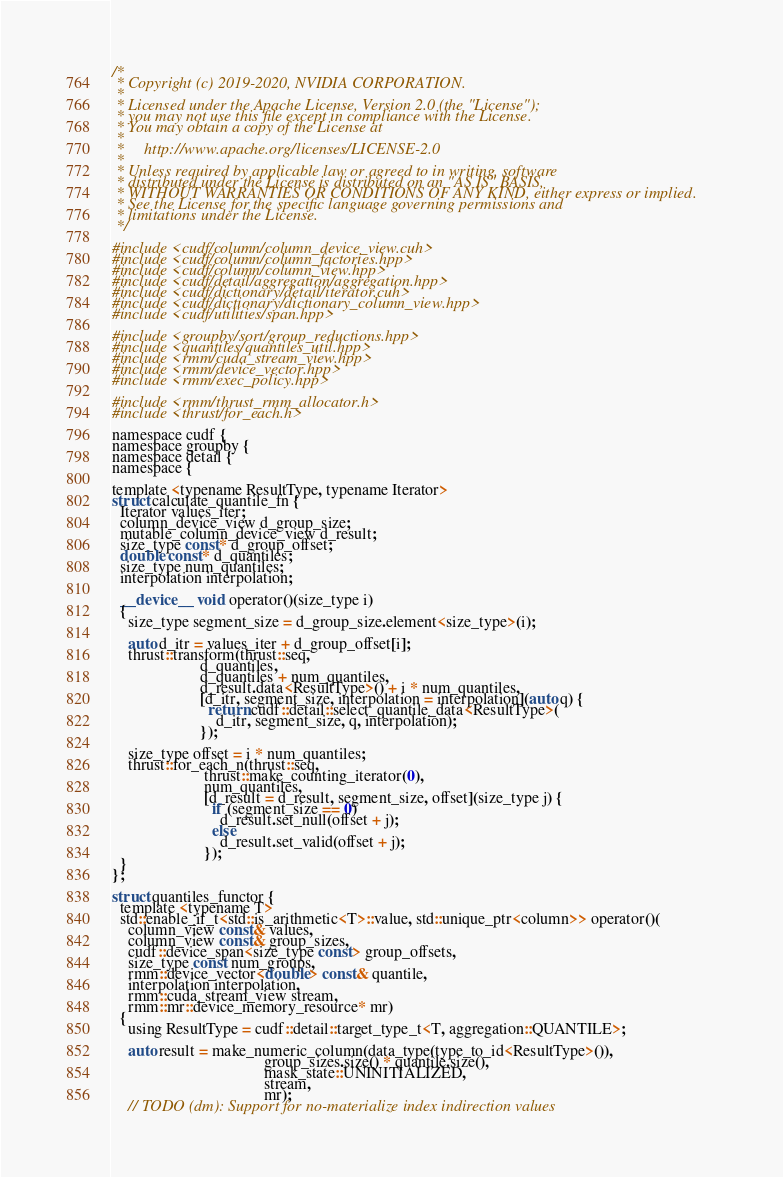Convert code to text. <code><loc_0><loc_0><loc_500><loc_500><_Cuda_>/*
 * Copyright (c) 2019-2020, NVIDIA CORPORATION.
 *
 * Licensed under the Apache License, Version 2.0 (the "License");
 * you may not use this file except in compliance with the License.
 * You may obtain a copy of the License at
 *
 *     http://www.apache.org/licenses/LICENSE-2.0
 *
 * Unless required by applicable law or agreed to in writing, software
 * distributed under the License is distributed on an "AS IS" BASIS,
 * WITHOUT WARRANTIES OR CONDITIONS OF ANY KIND, either express or implied.
 * See the License for the specific language governing permissions and
 * limitations under the License.
 */

#include <cudf/column/column_device_view.cuh>
#include <cudf/column/column_factories.hpp>
#include <cudf/column/column_view.hpp>
#include <cudf/detail/aggregation/aggregation.hpp>
#include <cudf/dictionary/detail/iterator.cuh>
#include <cudf/dictionary/dictionary_column_view.hpp>
#include <cudf/utilities/span.hpp>

#include <groupby/sort/group_reductions.hpp>
#include <quantiles/quantiles_util.hpp>
#include <rmm/cuda_stream_view.hpp>
#include <rmm/device_vector.hpp>
#include <rmm/exec_policy.hpp>

#include <rmm/thrust_rmm_allocator.h>
#include <thrust/for_each.h>

namespace cudf {
namespace groupby {
namespace detail {
namespace {

template <typename ResultType, typename Iterator>
struct calculate_quantile_fn {
  Iterator values_iter;
  column_device_view d_group_size;
  mutable_column_device_view d_result;
  size_type const* d_group_offset;
  double const* d_quantiles;
  size_type num_quantiles;
  interpolation interpolation;

  __device__ void operator()(size_type i)
  {
    size_type segment_size = d_group_size.element<size_type>(i);

    auto d_itr = values_iter + d_group_offset[i];
    thrust::transform(thrust::seq,
                      d_quantiles,
                      d_quantiles + num_quantiles,
                      d_result.data<ResultType>() + i * num_quantiles,
                      [d_itr, segment_size, interpolation = interpolation](auto q) {
                        return cudf::detail::select_quantile_data<ResultType>(
                          d_itr, segment_size, q, interpolation);
                      });

    size_type offset = i * num_quantiles;
    thrust::for_each_n(thrust::seq,
                       thrust::make_counting_iterator(0),
                       num_quantiles,
                       [d_result = d_result, segment_size, offset](size_type j) {
                         if (segment_size == 0)
                           d_result.set_null(offset + j);
                         else
                           d_result.set_valid(offset + j);
                       });
  }
};

struct quantiles_functor {
  template <typename T>
  std::enable_if_t<std::is_arithmetic<T>::value, std::unique_ptr<column>> operator()(
    column_view const& values,
    column_view const& group_sizes,
    cudf::device_span<size_type const> group_offsets,
    size_type const num_groups,
    rmm::device_vector<double> const& quantile,
    interpolation interpolation,
    rmm::cuda_stream_view stream,
    rmm::mr::device_memory_resource* mr)
  {
    using ResultType = cudf::detail::target_type_t<T, aggregation::QUANTILE>;

    auto result = make_numeric_column(data_type(type_to_id<ResultType>()),
                                      group_sizes.size() * quantile.size(),
                                      mask_state::UNINITIALIZED,
                                      stream,
                                      mr);
    // TODO (dm): Support for no-materialize index indirection values</code> 